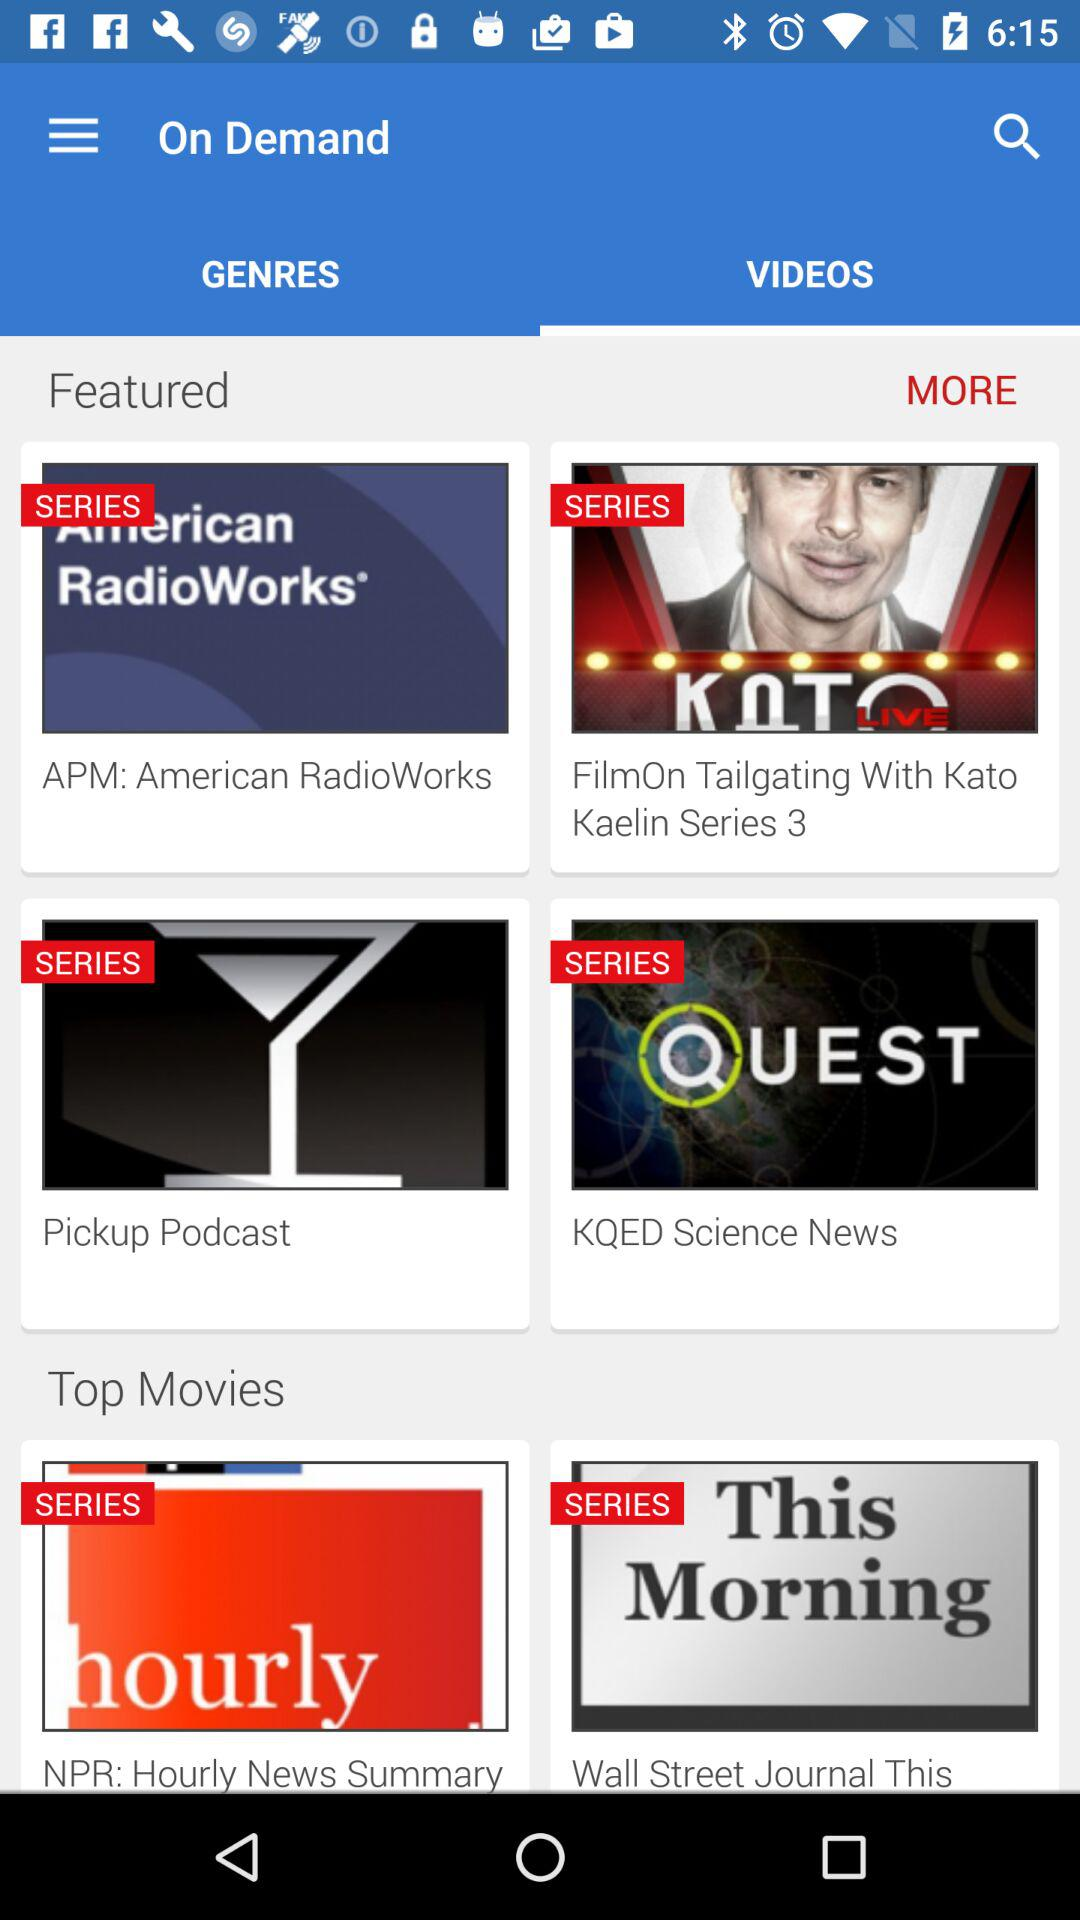Which tab is selected? The selected tab is "VIDEOS". 